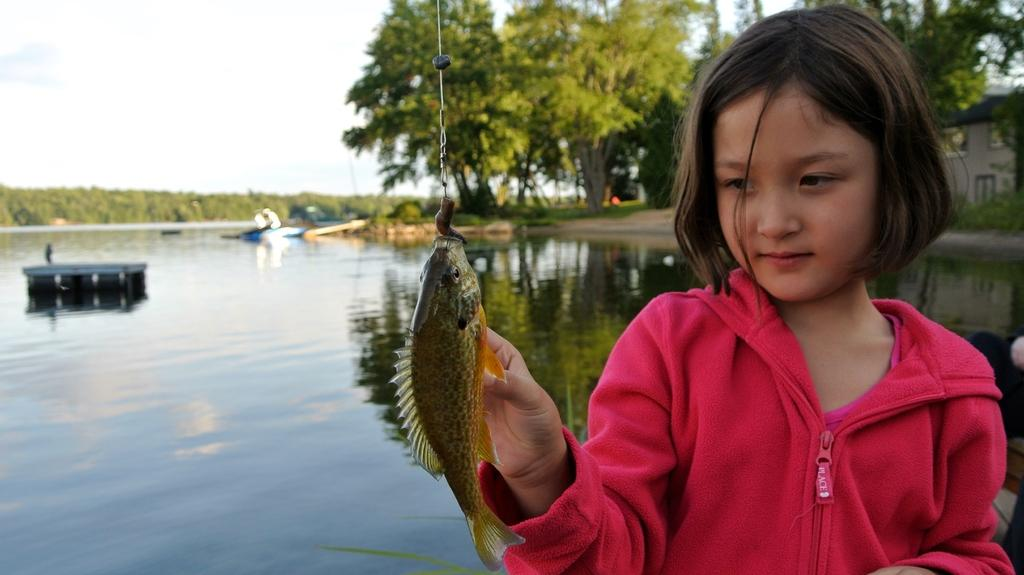Who is present in the image? There is a girl in the image. What is the girl doing in the image? The girl is touching a fish. How is the fish positioned in the image? The fish is hanged from the top. What can be seen in the background of the image? There is sky, trees, ships, persons, water, buildings, and ground visible in the background of the image. What color is the balloon floating above the girl in the image? There is no balloon present in the image. What type of arch can be seen in the background of the image? There is no arch visible in the background of the image. 